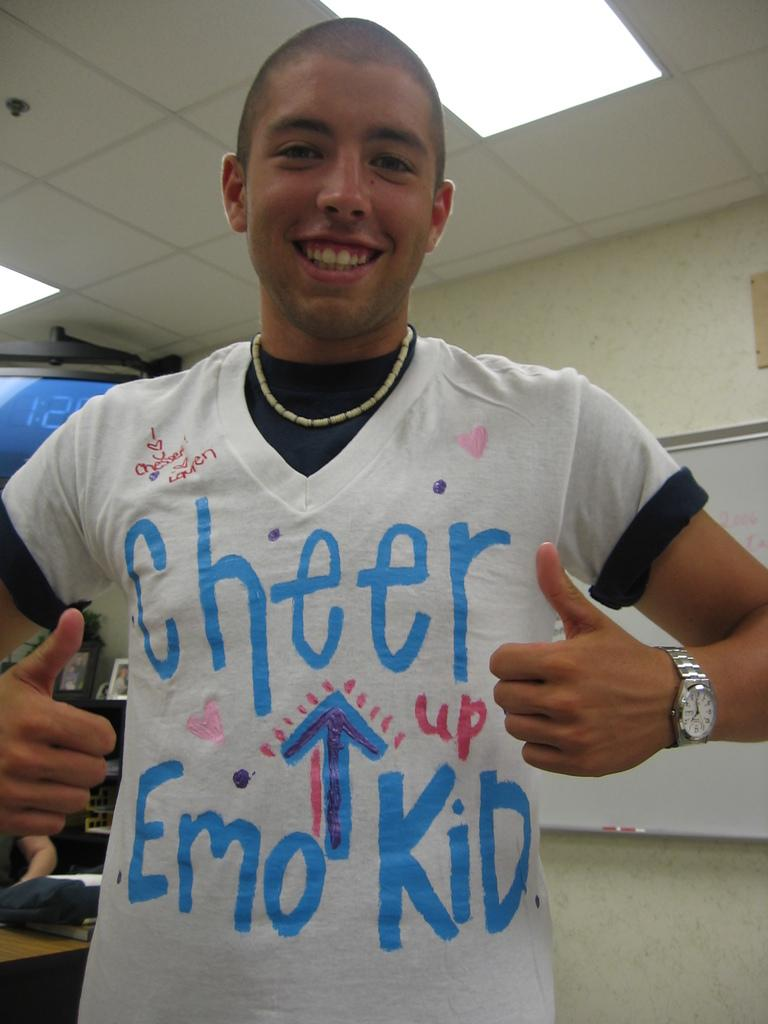<image>
Give a short and clear explanation of the subsequent image. A teenager in a "Cheer Up Emo Kid" t-shirt gives a double thumbs up. 